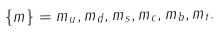<formula> <loc_0><loc_0><loc_500><loc_500>\{ m \} = m _ { u } , m _ { d } , m _ { s } , m _ { c } , m _ { b } , m _ { t } .</formula> 